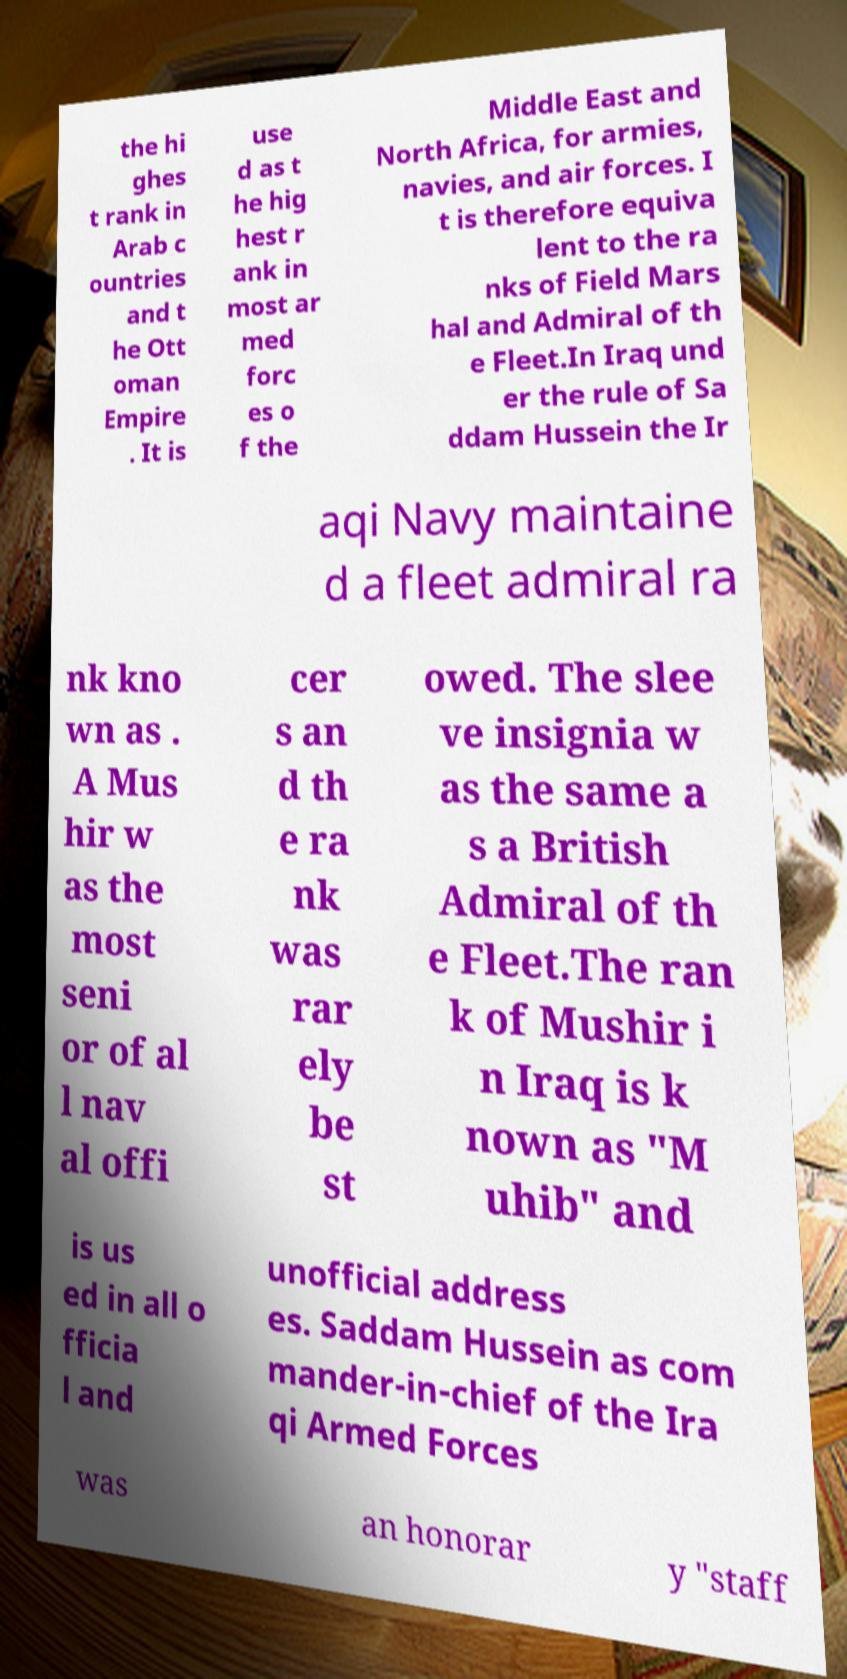Could you extract and type out the text from this image? the hi ghes t rank in Arab c ountries and t he Ott oman Empire . It is use d as t he hig hest r ank in most ar med forc es o f the Middle East and North Africa, for armies, navies, and air forces. I t is therefore equiva lent to the ra nks of Field Mars hal and Admiral of th e Fleet.In Iraq und er the rule of Sa ddam Hussein the Ir aqi Navy maintaine d a fleet admiral ra nk kno wn as . A Mus hir w as the most seni or of al l nav al offi cer s an d th e ra nk was rar ely be st owed. The slee ve insignia w as the same a s a British Admiral of th e Fleet.The ran k of Mushir i n Iraq is k nown as "M uhib" and is us ed in all o fficia l and unofficial address es. Saddam Hussein as com mander-in-chief of the Ira qi Armed Forces was an honorar y "staff 